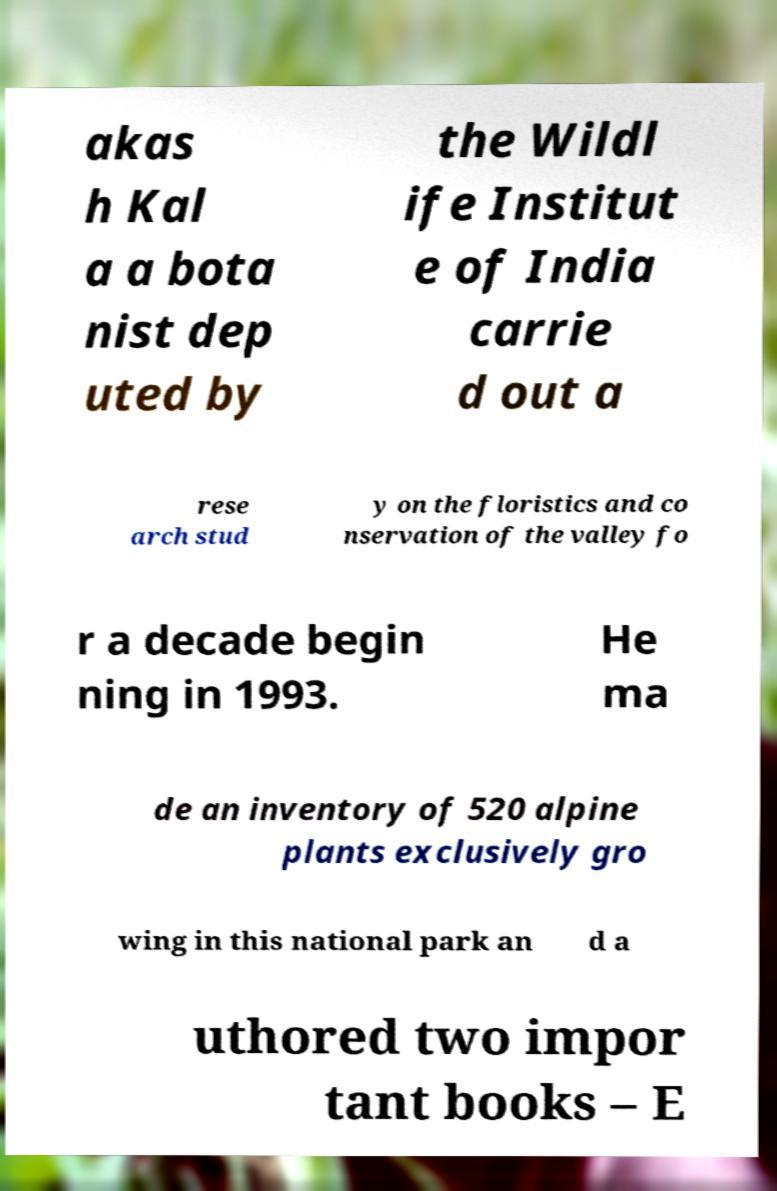Please read and relay the text visible in this image. What does it say? akas h Kal a a bota nist dep uted by the Wildl ife Institut e of India carrie d out a rese arch stud y on the floristics and co nservation of the valley fo r a decade begin ning in 1993. He ma de an inventory of 520 alpine plants exclusively gro wing in this national park an d a uthored two impor tant books – E 